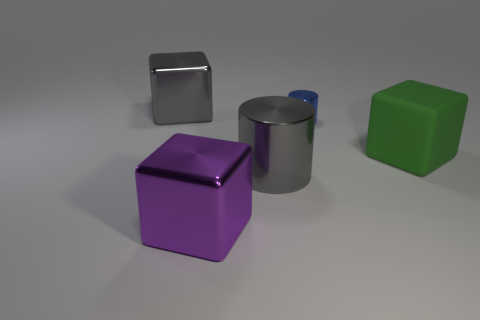Are there any other things that have the same size as the blue shiny object?
Your response must be concise. No. Are there more purple blocks than large blocks?
Offer a very short reply. No. There is a big block on the right side of the shiny cylinder behind the thing that is to the right of the small object; what is it made of?
Make the answer very short. Rubber. Is there a shiny cube of the same color as the big metallic cylinder?
Keep it short and to the point. Yes. What shape is the gray metal object that is the same size as the gray cylinder?
Give a very brief answer. Cube. Are there fewer metal blocks than green metallic cylinders?
Provide a short and direct response. No. How many purple shiny blocks have the same size as the matte thing?
Ensure brevity in your answer.  1. What shape is the metal object that is the same color as the big metallic cylinder?
Offer a very short reply. Cube. What is the material of the small thing?
Give a very brief answer. Metal. What is the size of the cylinder in front of the tiny thing?
Your answer should be very brief. Large. 